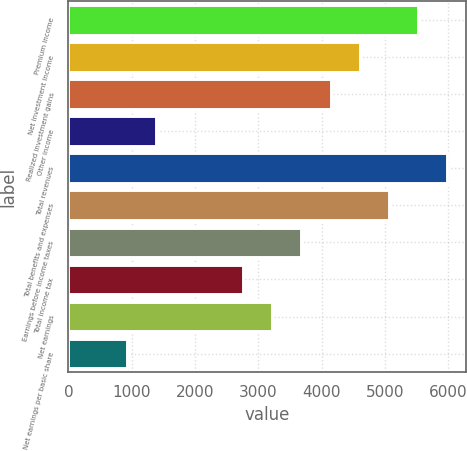Convert chart to OTSL. <chart><loc_0><loc_0><loc_500><loc_500><bar_chart><fcel>Premium income<fcel>Net investment income<fcel>Realized investment gains<fcel>Other income<fcel>Total revenues<fcel>Total benefits and expenses<fcel>Earnings before income taxes<fcel>Total income tax<fcel>Net earnings<fcel>Net earnings per basic share<nl><fcel>5516.32<fcel>4596.98<fcel>4137.31<fcel>1379.29<fcel>5975.99<fcel>5056.65<fcel>3677.64<fcel>2758.3<fcel>3217.97<fcel>919.62<nl></chart> 